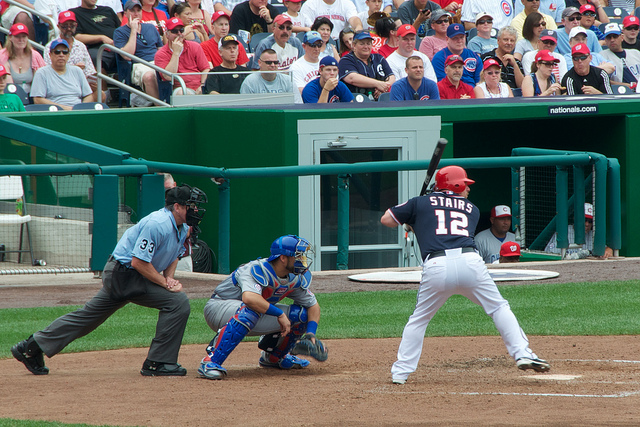Read all the text in this image. 33 12 